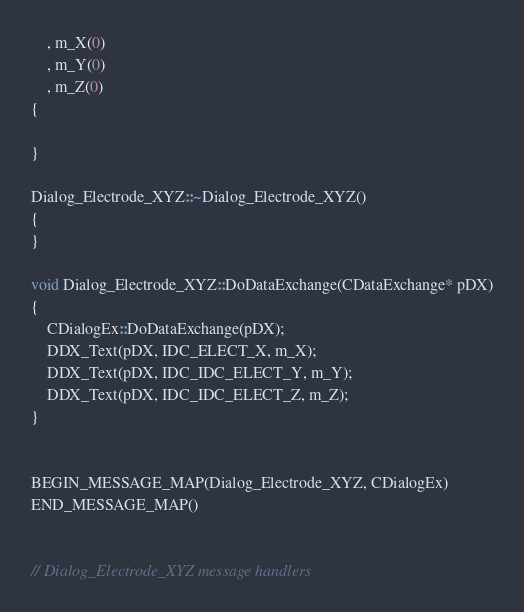Convert code to text. <code><loc_0><loc_0><loc_500><loc_500><_C++_>	, m_X(0)
	, m_Y(0)
	, m_Z(0)
{

}

Dialog_Electrode_XYZ::~Dialog_Electrode_XYZ()
{
}

void Dialog_Electrode_XYZ::DoDataExchange(CDataExchange* pDX)
{
	CDialogEx::DoDataExchange(pDX);
	DDX_Text(pDX, IDC_ELECT_X, m_X);
	DDX_Text(pDX, IDC_IDC_ELECT_Y, m_Y);
	DDX_Text(pDX, IDC_IDC_ELECT_Z, m_Z);
}


BEGIN_MESSAGE_MAP(Dialog_Electrode_XYZ, CDialogEx)
END_MESSAGE_MAP()


// Dialog_Electrode_XYZ message handlers
</code> 